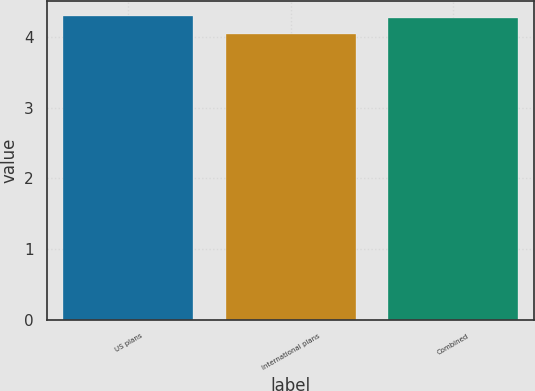Convert chart to OTSL. <chart><loc_0><loc_0><loc_500><loc_500><bar_chart><fcel>US plans<fcel>International plans<fcel>Combined<nl><fcel>4.3<fcel>4.04<fcel>4.27<nl></chart> 